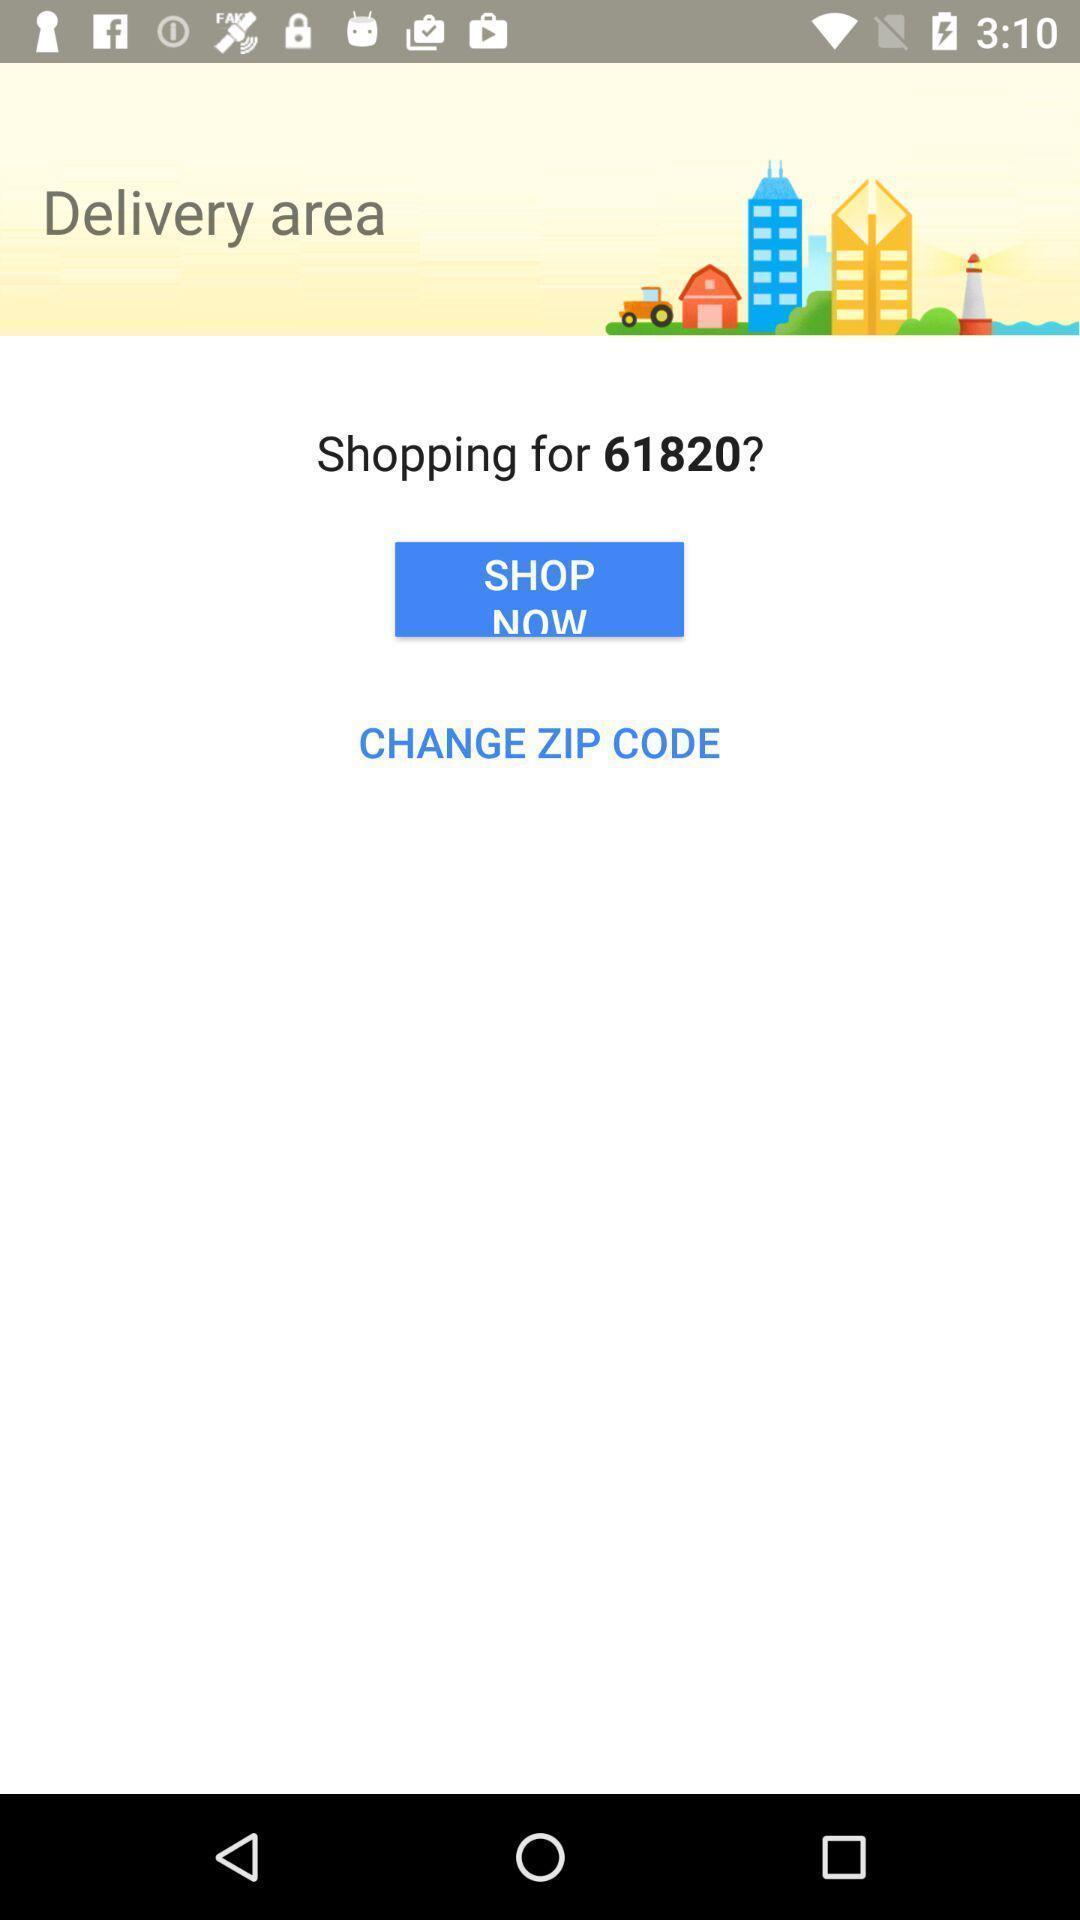What details can you identify in this image? Page showing delivery area in a shopping app. 